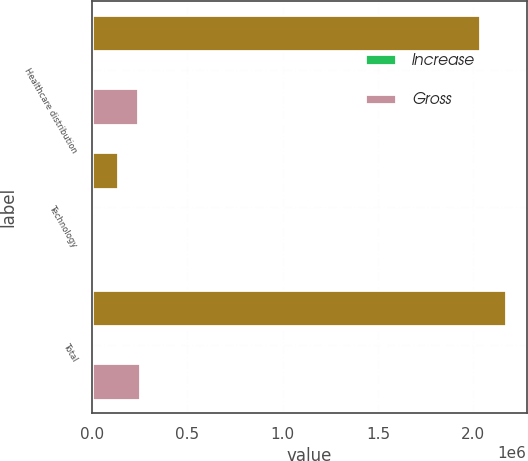Convert chart to OTSL. <chart><loc_0><loc_0><loc_500><loc_500><stacked_bar_chart><ecel><fcel>Healthcare distribution<fcel>Technology<fcel>Total<nl><fcel>nan<fcel>2.03386e+06<fcel>137016<fcel>2.17088e+06<nl><fcel>Increase<fcel>27.8<fcel>68.5<fcel>28.8<nl><fcel>Gross<fcel>241344<fcel>12712<fcel>254056<nl></chart> 